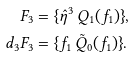<formula> <loc_0><loc_0><loc_500><loc_500>F _ { 3 } & = \{ \hat { \eta } ^ { 3 } \, Q _ { 1 } ( f _ { 1 } ) \} , \\ d _ { 3 } F _ { 3 } & = \{ f _ { 1 } \, \tilde { Q } _ { 0 } ( f _ { 1 } ) \} .</formula> 